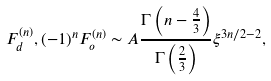<formula> <loc_0><loc_0><loc_500><loc_500>F _ { d } ^ { ( n ) } , ( - 1 ) ^ { n } F _ { o } ^ { ( n ) } \sim A \frac { \Gamma \left ( n - \frac { 4 } { 3 } \right ) } { \Gamma \left ( \frac { 2 } { 3 } \right ) } \xi ^ { 3 n / 2 - 2 } ,</formula> 